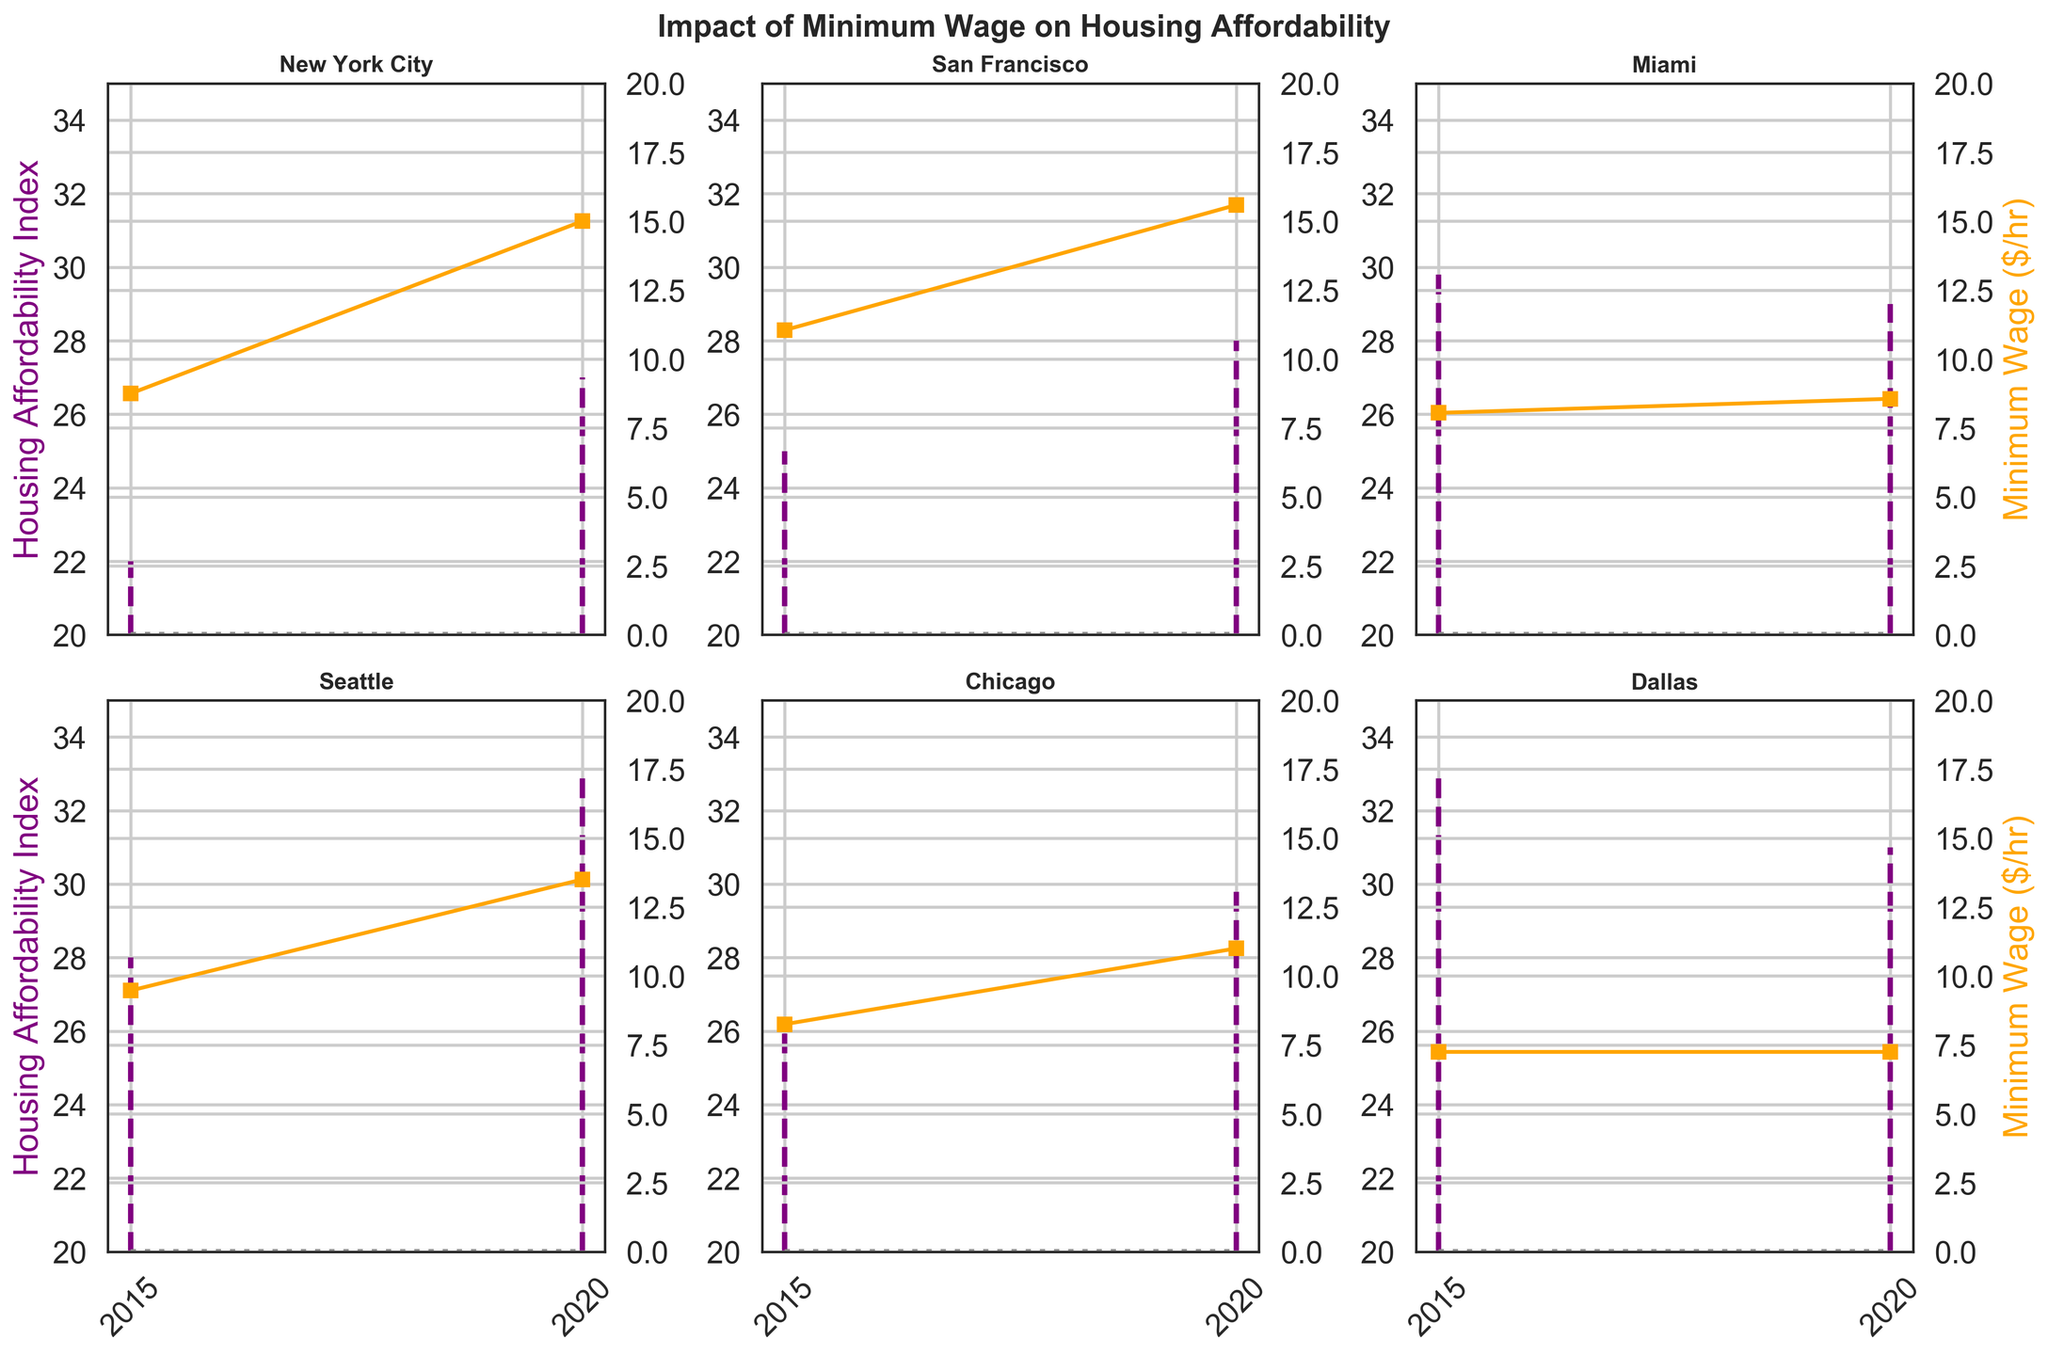What is the title of the figure? The title is displayed at the top of the figure and reads "Impact of Minimum Wage on Housing Affordability".
Answer: "Impact of Minimum Wage on Housing Affordability" Which region has the highest minimum wage in 2020? Looking at the orange line representing the minimum wage for each region in 2020, San Francisco has the highest value of $15.59.
Answer: San Francisco What is the change in the Housing Affordability Index for Miami between 2015 and 2020? The stem points for Miami show the Housing Affordability Index was 30 in 2015 and 29 in 2020. Thus, the change is 30 - 29 = 1 decrease.
Answer: -1 Which region shows the largest increase in minimum wage from 2015 to 2020? By comparing the differences in the height of the orange line segments, New York City shows the largest increase, from $8.75 to $15.00, a jump of $6.25.
Answer: New York City Is the Housing Affordability Index higher in Seattle or Dallas in 2020? The 2020 stem plot for Seattle shows an affordability index of 33, while for Dallas it shows 31; therefore, Seattle's is higher.
Answer: Seattle How does the trend in minimum wage compare to the trend in the affordability index in New York City? In New York City, the stem plot shows an increase in the Housing Affordability Index from 22 in 2015 to 27 in 2020. The orange line shows the minimum wage increasing from $8.75 to $15.00 in the same period. Both metrics increase over time.
Answer: Both increase Which region had a decrease in the Housing Affordability Index from 2015 to 2020? By examining the stem plots, Miami is the only region where the Housing Affordability Index decreased from 30 to 29.
Answer: Miami In which region is the minimum wage unchanged between 2015 and 2020? Observing the orange line, Dallas has the same minimum wage of $7.25 in both 2015 and 2020, indicating no change.
Answer: Dallas What is the range of the Housing Affordability Index in San Francisco in the plotted years? The plot shows the Housing Affordability Index for San Francisco as 25 in 2015 and 28 in 2020, giving a range of 28 - 25 = 3.
Answer: 3 